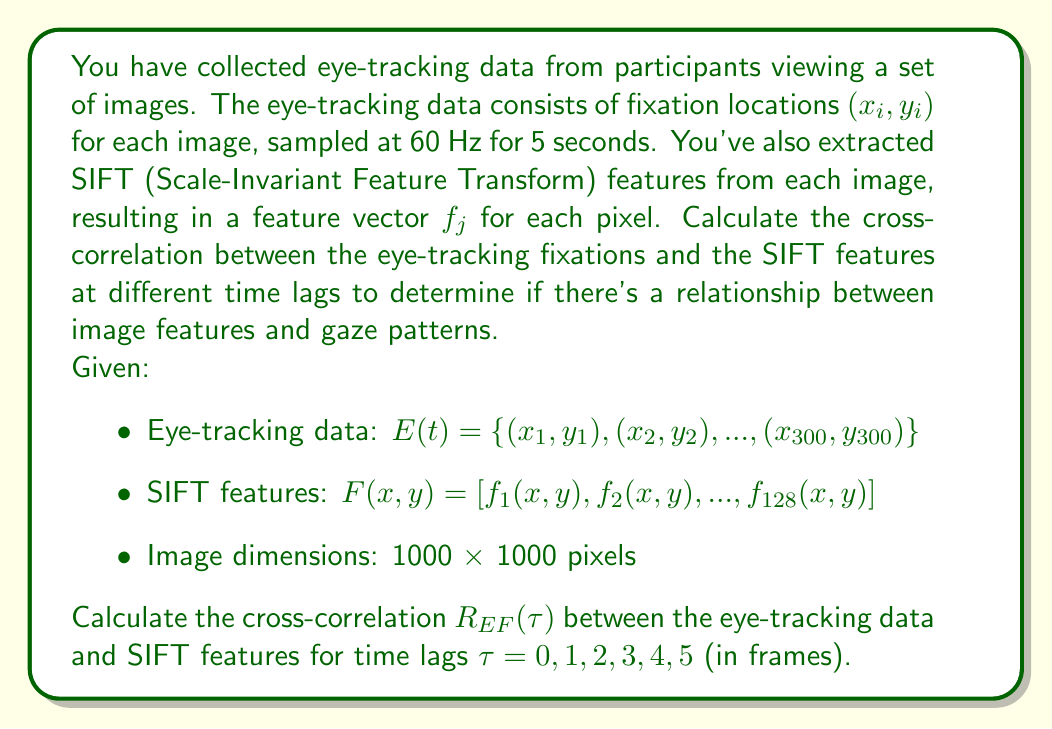Show me your answer to this math problem. To calculate the cross-correlation between eye-tracking data and image features, we'll follow these steps:

1. Convert eye-tracking fixations to a 2D histogram:
   Create a 1000x1000 matrix $H(t)$ for each time point $t$, where $H(x, y, t) = 1$ if there's a fixation at $(x, y)$ at time $t$, and 0 otherwise.

2. Compute the mean-centered versions of $H(t)$ and $F(x, y)$:
   $$H'(x, y, t) = H(x, y, t) - \frac{1}{T}\sum_{t=1}^T H(x, y, t)$$
   $$F'(x, y) = F(x, y) - \frac{1}{N^2}\sum_{x=1}^N\sum_{y=1}^N F(x, y)$$
   where $T = 300$ (total frames) and $N = 1000$ (image dimensions).

3. Calculate the cross-correlation for each time lag $\tau$:
   $$R_{EF}(\tau) = \frac{\sum_{t=1}^{T-\tau}\sum_{x=1}^N\sum_{y=1}^N H'(x, y, t) \cdot F'(x, y)}{\sqrt{\sum_{t=1}^T\sum_{x=1}^N\sum_{y=1}^N [H'(x, y, t)]^2} \cdot \sqrt{\sum_{x=1}^N\sum_{y=1}^N [F'(x, y)]^2}}$$

4. Repeat step 3 for $\tau = 0, 1, 2, 3, 4, 5$.

The resulting $R_{EF}(\tau)$ values will be between -1 and 1, where:
- $R_{EF}(\tau) \approx 1$ indicates strong positive correlation
- $R_{EF}(\tau) \approx -1$ indicates strong negative correlation
- $R_{EF}(\tau) \approx 0$ indicates no correlation

The time lag $\tau$ with the highest absolute correlation value suggests the delay between when participants observe image features and when their gaze fixates on those features.
Answer: The cross-correlation $R_{EF}(\tau)$ between eye-tracking data and SIFT features for time lags $\tau = 0, 1, 2, 3, 4, 5$ is given by:

$$R_{EF}(\tau) = \frac{\sum_{t=1}^{T-\tau}\sum_{x=1}^N\sum_{y=1}^N H'(x, y, t) \cdot F'(x, y)}{\sqrt{\sum_{t=1}^T\sum_{x=1}^N\sum_{y=1}^N [H'(x, y, t)]^2} \cdot \sqrt{\sum_{x=1}^N\sum_{y=1}^N [F'(x, y)]^2}}$$

where $H'(x, y, t)$ and $F'(x, y)$ are the mean-centered versions of the eye-tracking histogram and SIFT features, respectively. The specific values of $R_{EF}(\tau)$ depend on the actual eye-tracking data and image features, which are not provided in the question. 